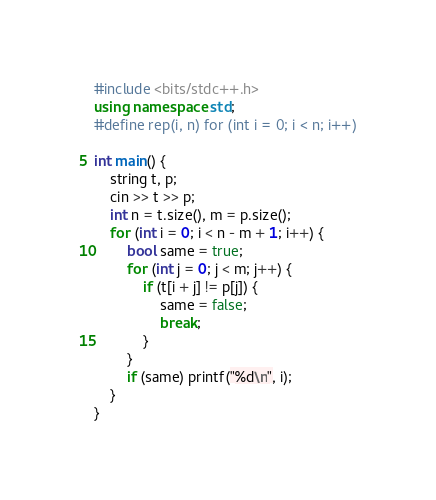Convert code to text. <code><loc_0><loc_0><loc_500><loc_500><_C++_>#include <bits/stdc++.h>
using namespace std;
#define rep(i, n) for (int i = 0; i < n; i++)

int main() {
    string t, p;
    cin >> t >> p;
    int n = t.size(), m = p.size();
    for (int i = 0; i < n - m + 1; i++) {
        bool same = true;
        for (int j = 0; j < m; j++) {
            if (t[i + j] != p[j]) {
                same = false;
                break;
            }
        }
        if (same) printf("%d\n", i);
    }
}
</code> 